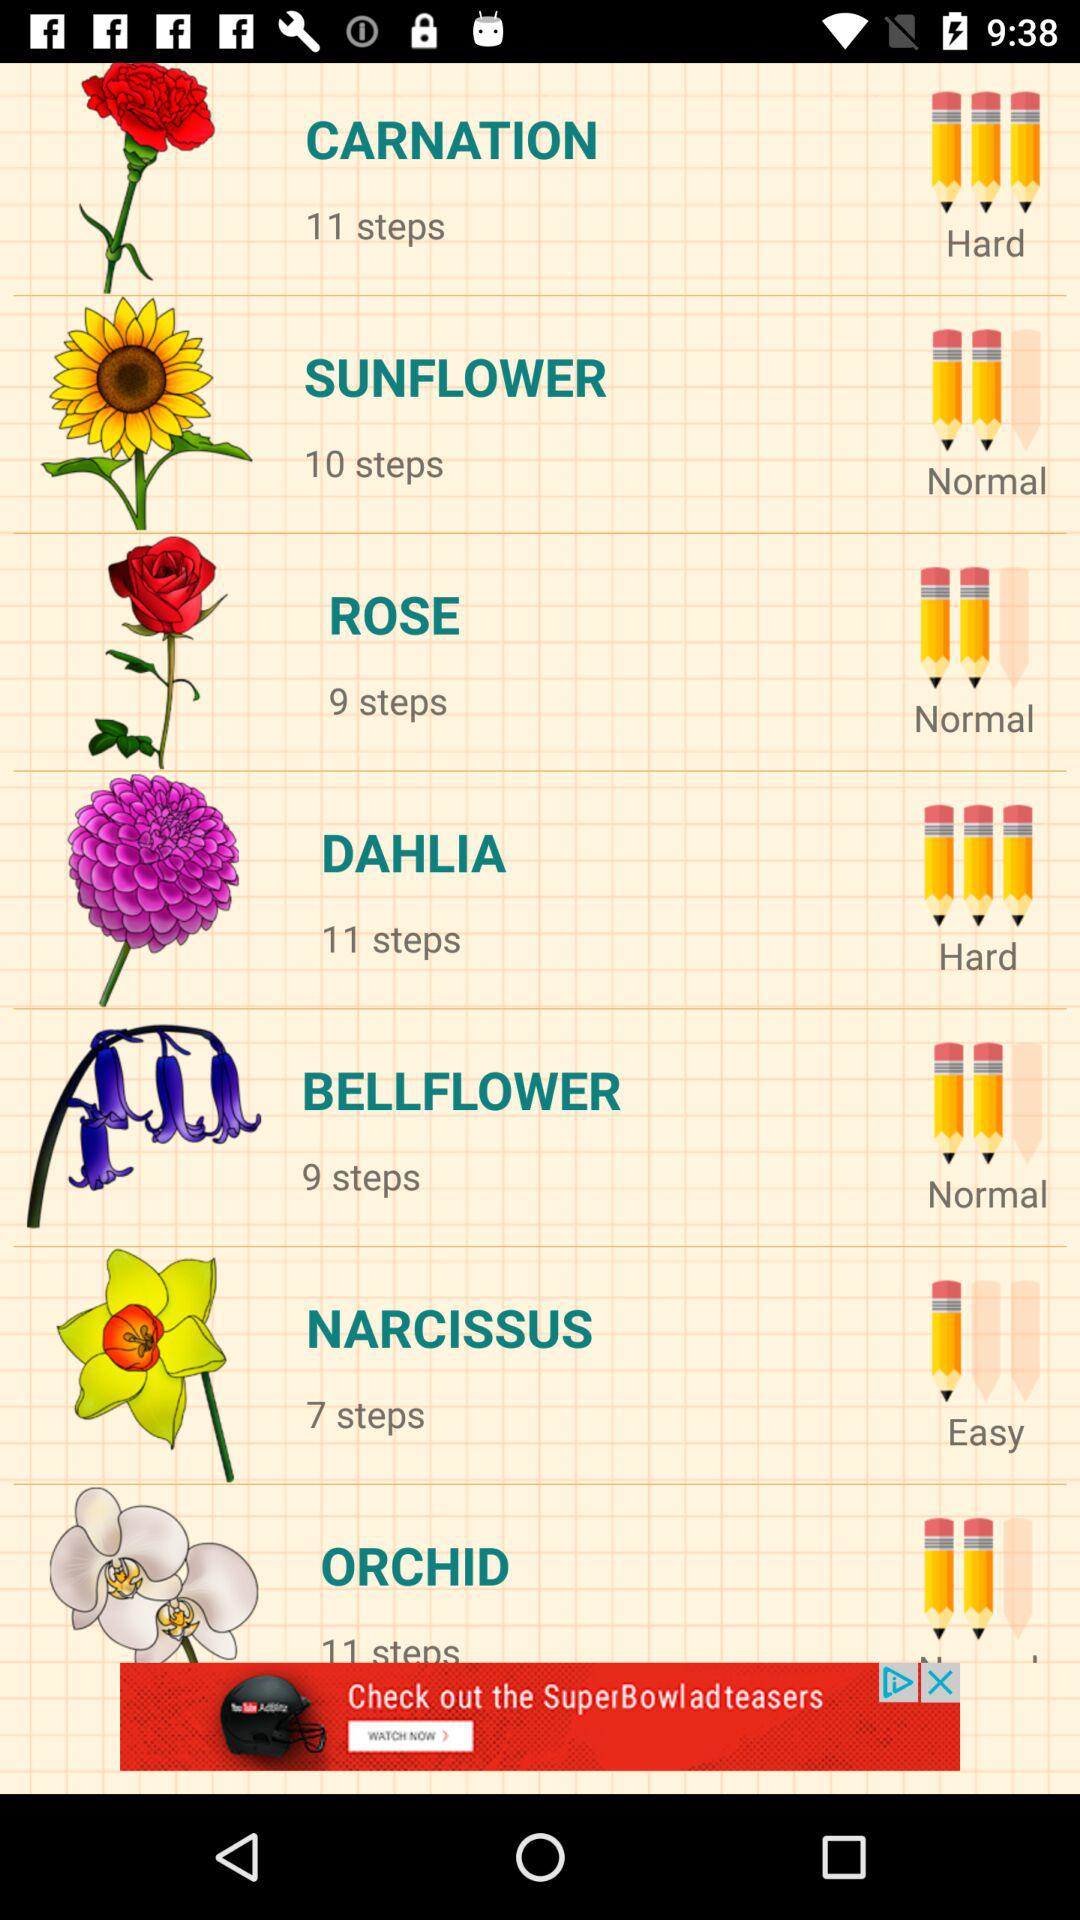What's the drawing level of "ROSE"? The drawing level of "ROSE" is normal. 